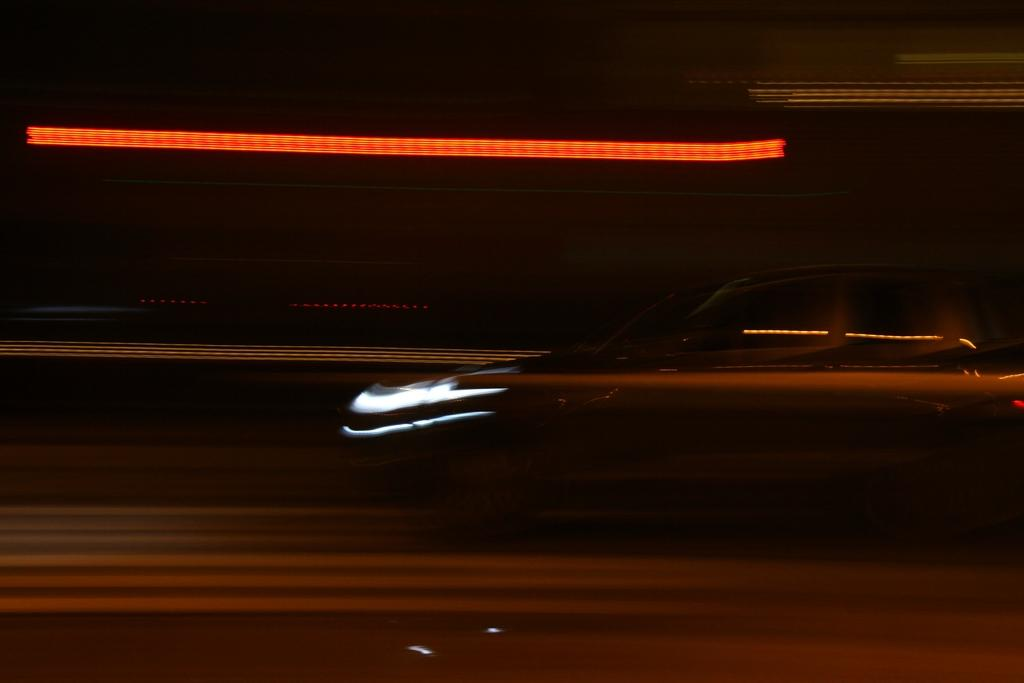What is the main subject of the image? The main subject of the image is a car. Where is the car located? The car is on a road. What can be observed about the background of the image? The background of the image is dark. What word is written on the side of the car in the image? There is no word written on the side of the car in the image. Is there a fire hydrant visible in the image? There is no fire hydrant present in the image. 